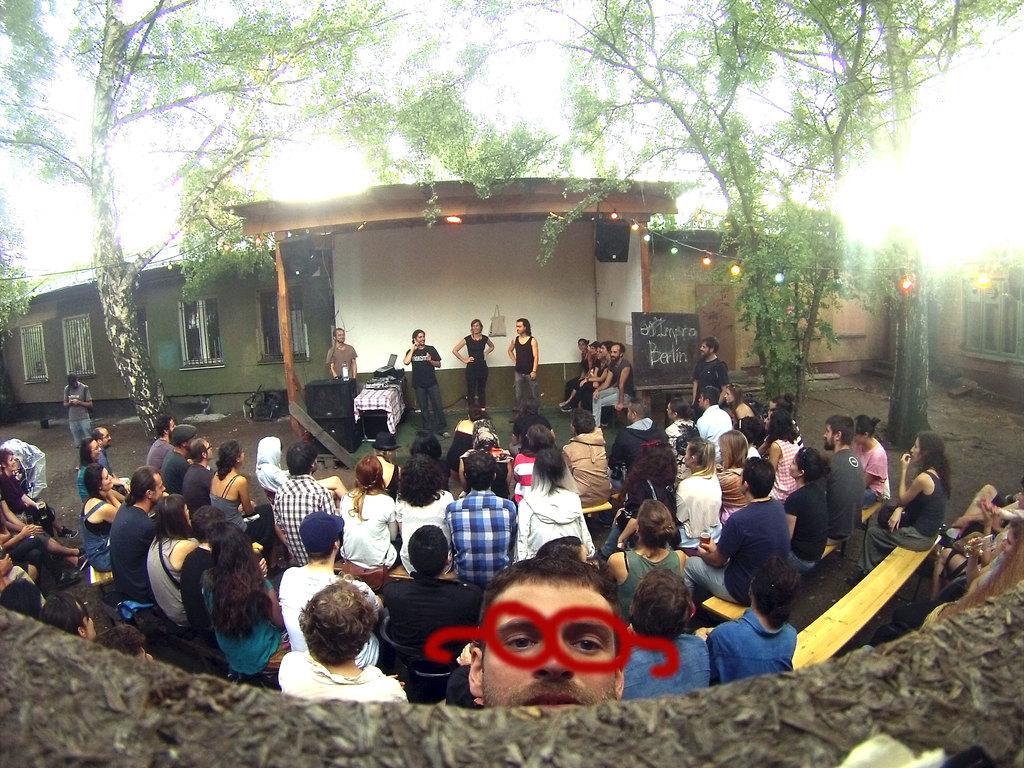Can you describe this image briefly? This image consists of many people sitting on the benches. At the bottom, there is a wall. In the background there are few people talking. To the right, there is a board. In the background there is a building along with trees. 